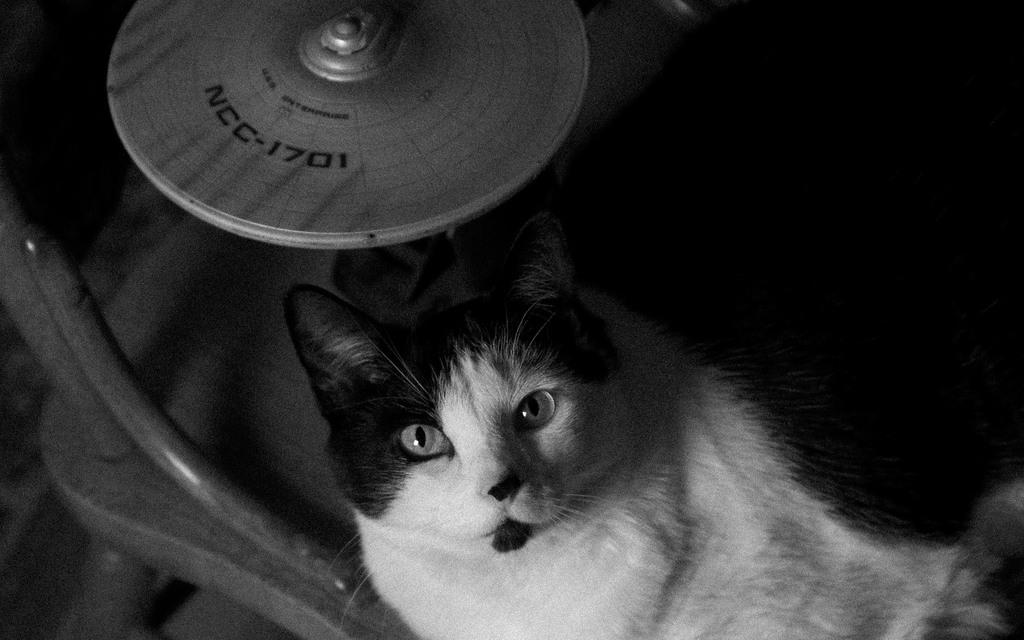What animal is at the bottom of the image? There is a cat at the bottom of the image. What piece of furniture is on the left side of the image? There is a chair on the left side of the image. What object is at the top of the image? There is a disc at the top of the image. How much weight can the cat lift in the image? There is no indication of the cat lifting any weight in the image. What type of error is being made by the disc in the image? There is no error being made by the disc in the image; it is simply an object at the top of the image. 